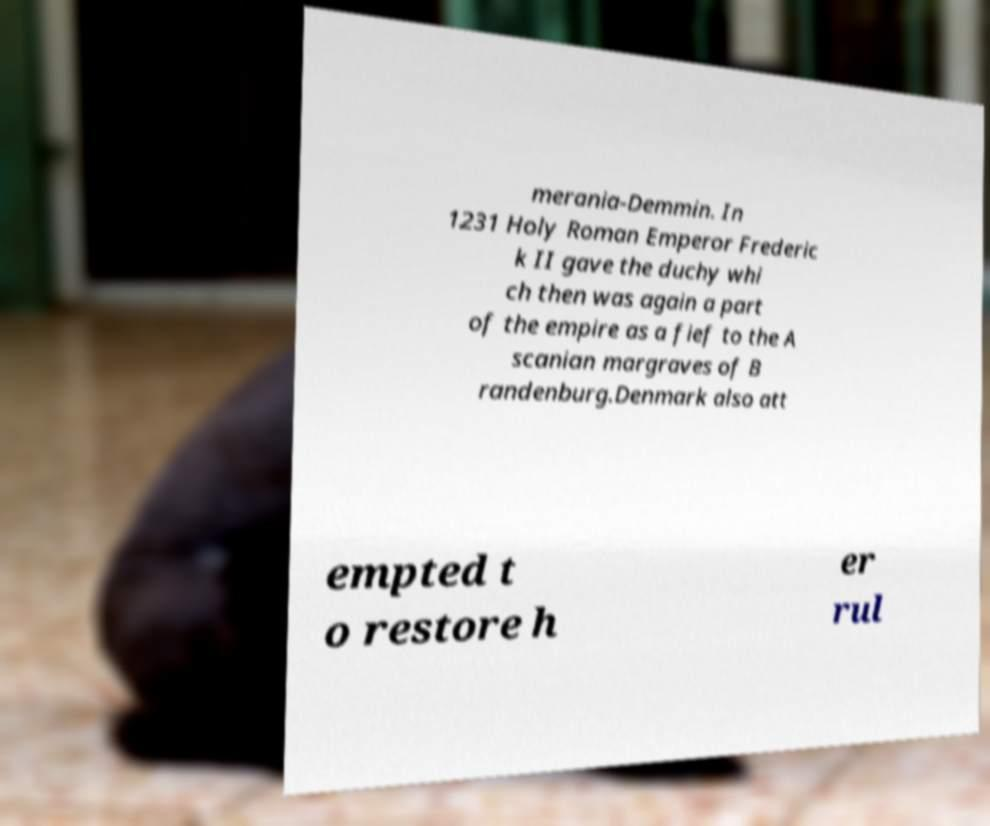Please read and relay the text visible in this image. What does it say? merania-Demmin. In 1231 Holy Roman Emperor Frederic k II gave the duchy whi ch then was again a part of the empire as a fief to the A scanian margraves of B randenburg.Denmark also att empted t o restore h er rul 